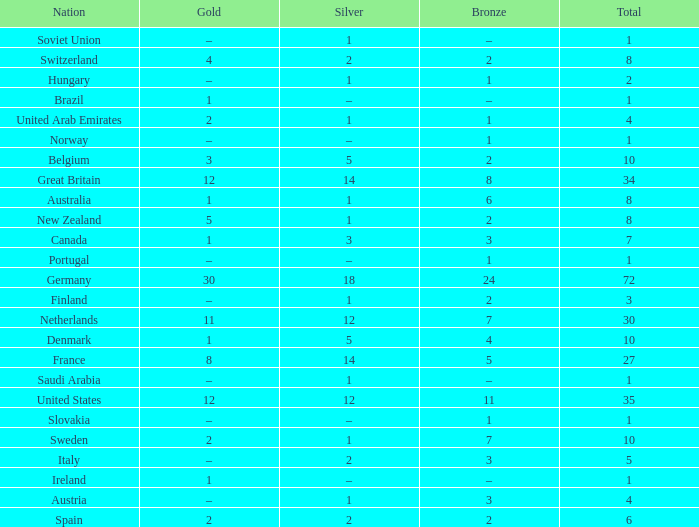What is the total number of Total, when Silver is 1, and when Bronze is 7? 1.0. 